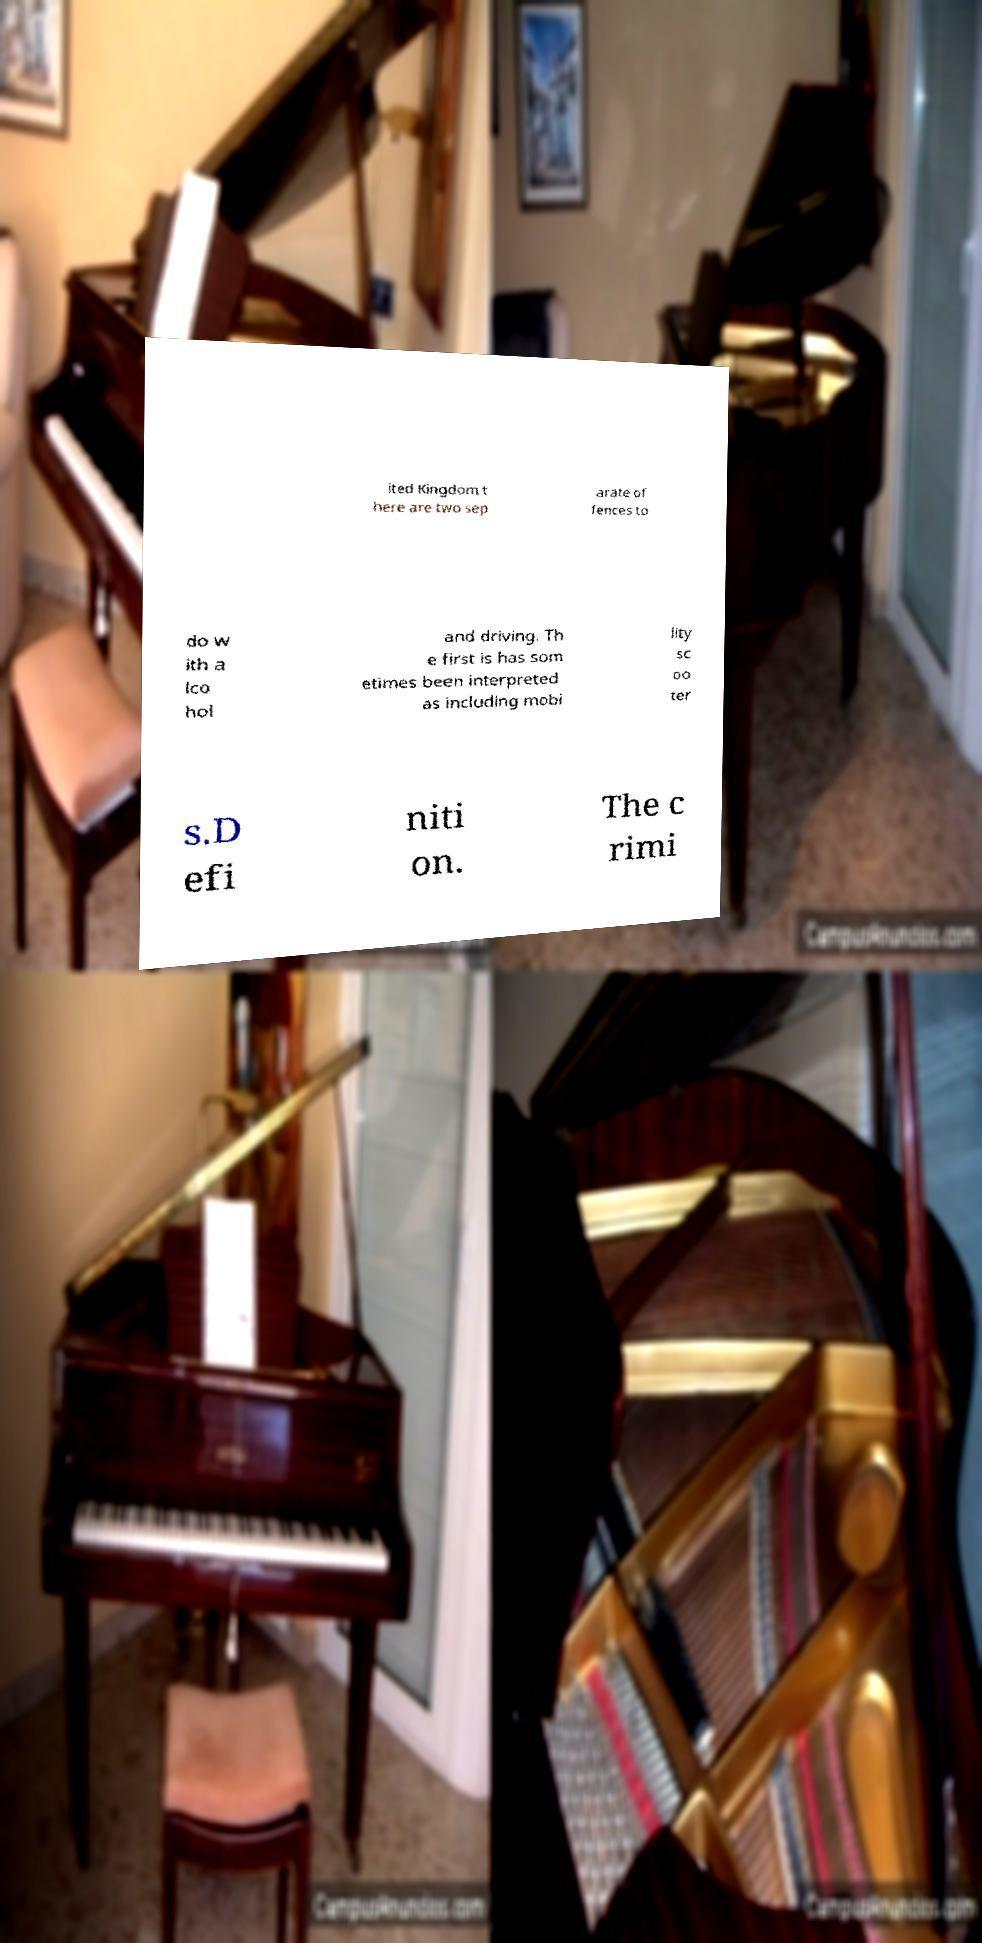Could you assist in decoding the text presented in this image and type it out clearly? ited Kingdom t here are two sep arate of fences to do w ith a lco hol and driving. Th e first is has som etimes been interpreted as including mobi lity sc oo ter s.D efi niti on. The c rimi 